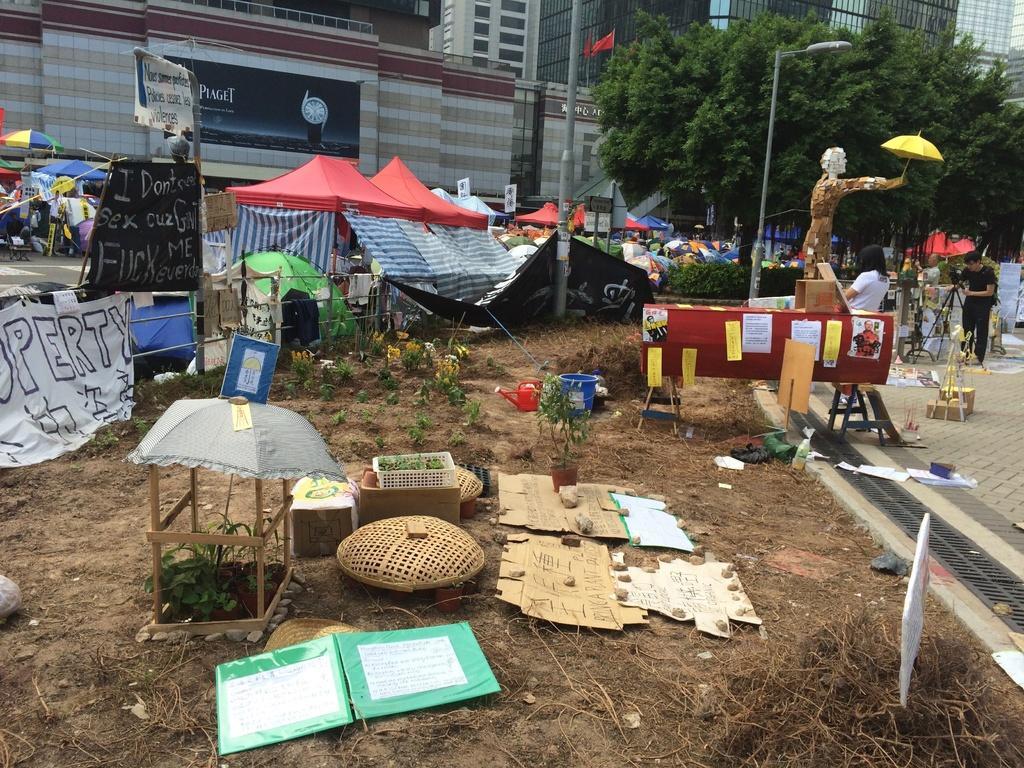Describe this image in one or two sentences. The picture is taken outside the city. In the foreground of the picture there are plants, buckets, baskets, stones, papers, twigs, banner and hoarding. On the right there are people standing and writing. In the center of the picture there are trees, buildings, plants and tents. 